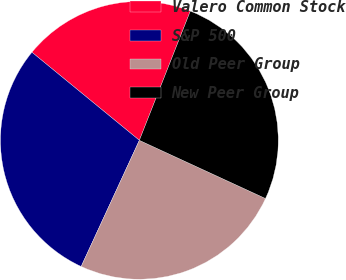Convert chart. <chart><loc_0><loc_0><loc_500><loc_500><pie_chart><fcel>Valero Common Stock<fcel>S&P 500<fcel>Old Peer Group<fcel>New Peer Group<nl><fcel>20.05%<fcel>29.05%<fcel>25.0%<fcel>25.9%<nl></chart> 